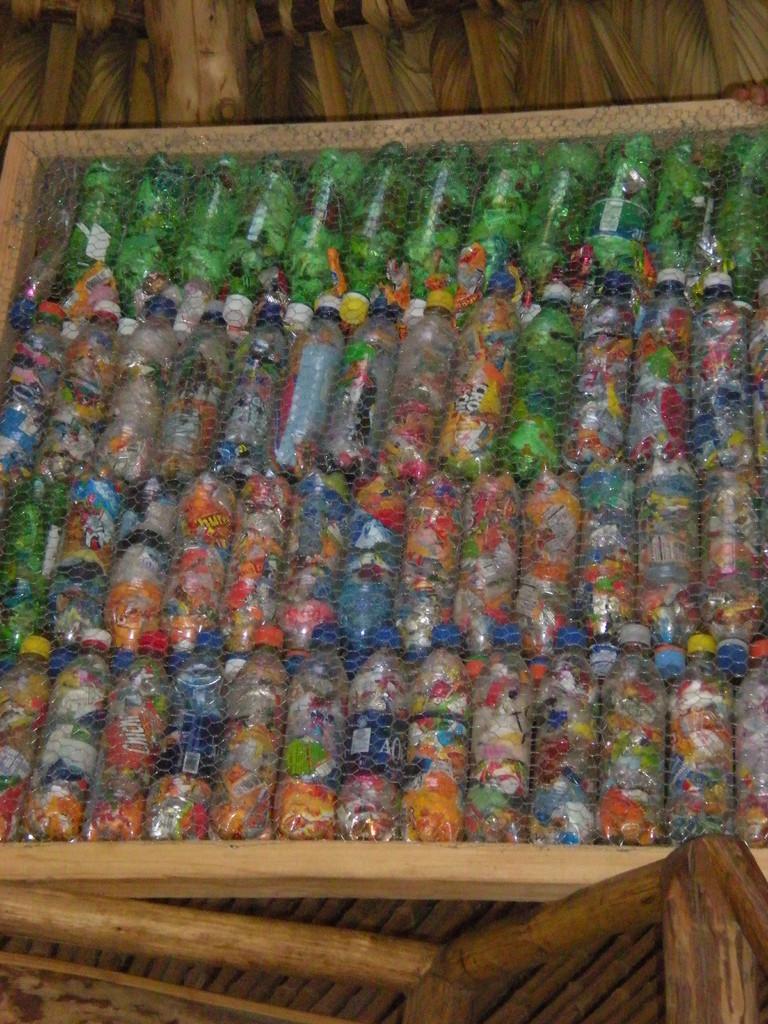Please provide a concise description of this image. These are the colorful multiple bottles arranged in a pattern. These bottles are in four rows. These bottles are sealed with a thin fencing sheet. At background this looks like a wooden structure. 